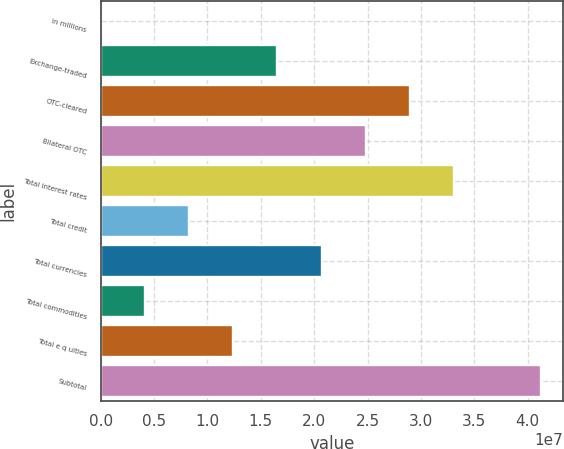Convert chart to OTSL. <chart><loc_0><loc_0><loc_500><loc_500><bar_chart><fcel>in millions<fcel>Exchange-traded<fcel>OTC-cleared<fcel>Bilateral OTC<fcel>Total interest rates<fcel>Total credit<fcel>Total currencies<fcel>Total commodities<fcel>Total e q uities<fcel>Subtotal<nl><fcel>2016<fcel>1.65514e+07<fcel>2.89635e+07<fcel>2.48261e+07<fcel>3.31008e+07<fcel>8.27672e+06<fcel>2.06888e+07<fcel>4.13937e+06<fcel>1.24141e+07<fcel>4.12734e+07<nl></chart> 